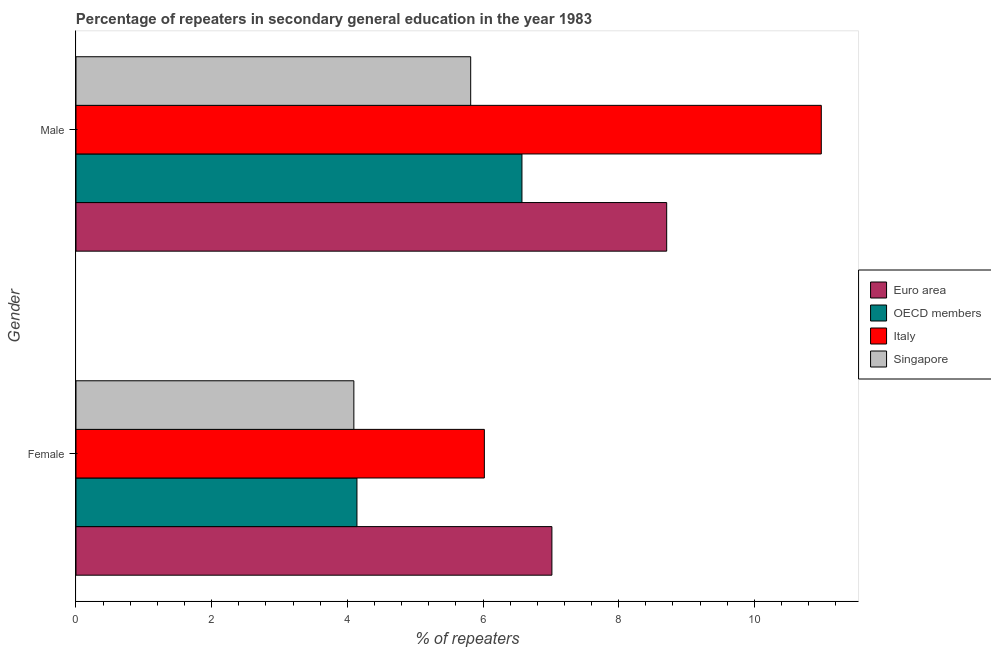Are the number of bars per tick equal to the number of legend labels?
Your answer should be very brief. Yes. Are the number of bars on each tick of the Y-axis equal?
Ensure brevity in your answer.  Yes. How many bars are there on the 2nd tick from the top?
Ensure brevity in your answer.  4. How many bars are there on the 1st tick from the bottom?
Offer a terse response. 4. What is the label of the 2nd group of bars from the top?
Ensure brevity in your answer.  Female. What is the percentage of male repeaters in Italy?
Your answer should be very brief. 10.99. Across all countries, what is the maximum percentage of female repeaters?
Ensure brevity in your answer.  7.02. Across all countries, what is the minimum percentage of male repeaters?
Give a very brief answer. 5.82. In which country was the percentage of male repeaters minimum?
Make the answer very short. Singapore. What is the total percentage of male repeaters in the graph?
Give a very brief answer. 32.09. What is the difference between the percentage of female repeaters in OECD members and that in Singapore?
Ensure brevity in your answer.  0.05. What is the difference between the percentage of male repeaters in Italy and the percentage of female repeaters in OECD members?
Your answer should be compact. 6.84. What is the average percentage of female repeaters per country?
Provide a succinct answer. 5.32. What is the difference between the percentage of female repeaters and percentage of male repeaters in OECD members?
Ensure brevity in your answer.  -2.43. What is the ratio of the percentage of female repeaters in Euro area to that in Singapore?
Your answer should be compact. 1.71. What does the 2nd bar from the top in Male represents?
Provide a succinct answer. Italy. What does the 4th bar from the bottom in Male represents?
Keep it short and to the point. Singapore. How many countries are there in the graph?
Your answer should be compact. 4. Does the graph contain any zero values?
Make the answer very short. No. Does the graph contain grids?
Your response must be concise. No. Where does the legend appear in the graph?
Ensure brevity in your answer.  Center right. What is the title of the graph?
Make the answer very short. Percentage of repeaters in secondary general education in the year 1983. Does "Kyrgyz Republic" appear as one of the legend labels in the graph?
Your answer should be compact. No. What is the label or title of the X-axis?
Your response must be concise. % of repeaters. What is the % of repeaters of Euro area in Female?
Provide a succinct answer. 7.02. What is the % of repeaters of OECD members in Female?
Provide a short and direct response. 4.14. What is the % of repeaters in Italy in Female?
Your answer should be compact. 6.02. What is the % of repeaters in Singapore in Female?
Make the answer very short. 4.1. What is the % of repeaters of Euro area in Male?
Ensure brevity in your answer.  8.71. What is the % of repeaters in OECD members in Male?
Provide a short and direct response. 6.57. What is the % of repeaters in Italy in Male?
Provide a short and direct response. 10.99. What is the % of repeaters in Singapore in Male?
Offer a terse response. 5.82. Across all Gender, what is the maximum % of repeaters in Euro area?
Provide a succinct answer. 8.71. Across all Gender, what is the maximum % of repeaters in OECD members?
Offer a terse response. 6.57. Across all Gender, what is the maximum % of repeaters of Italy?
Offer a very short reply. 10.99. Across all Gender, what is the maximum % of repeaters in Singapore?
Your answer should be very brief. 5.82. Across all Gender, what is the minimum % of repeaters in Euro area?
Offer a terse response. 7.02. Across all Gender, what is the minimum % of repeaters in OECD members?
Keep it short and to the point. 4.14. Across all Gender, what is the minimum % of repeaters of Italy?
Provide a short and direct response. 6.02. Across all Gender, what is the minimum % of repeaters in Singapore?
Offer a terse response. 4.1. What is the total % of repeaters of Euro area in the graph?
Offer a very short reply. 15.72. What is the total % of repeaters in OECD members in the graph?
Ensure brevity in your answer.  10.72. What is the total % of repeaters in Italy in the graph?
Ensure brevity in your answer.  17.01. What is the total % of repeaters in Singapore in the graph?
Your answer should be compact. 9.91. What is the difference between the % of repeaters of Euro area in Female and that in Male?
Offer a terse response. -1.69. What is the difference between the % of repeaters in OECD members in Female and that in Male?
Give a very brief answer. -2.43. What is the difference between the % of repeaters in Italy in Female and that in Male?
Provide a short and direct response. -4.97. What is the difference between the % of repeaters in Singapore in Female and that in Male?
Offer a terse response. -1.72. What is the difference between the % of repeaters of Euro area in Female and the % of repeaters of OECD members in Male?
Your answer should be compact. 0.44. What is the difference between the % of repeaters of Euro area in Female and the % of repeaters of Italy in Male?
Your answer should be very brief. -3.97. What is the difference between the % of repeaters in Euro area in Female and the % of repeaters in Singapore in Male?
Provide a succinct answer. 1.2. What is the difference between the % of repeaters in OECD members in Female and the % of repeaters in Italy in Male?
Ensure brevity in your answer.  -6.84. What is the difference between the % of repeaters in OECD members in Female and the % of repeaters in Singapore in Male?
Ensure brevity in your answer.  -1.68. What is the difference between the % of repeaters in Italy in Female and the % of repeaters in Singapore in Male?
Provide a short and direct response. 0.2. What is the average % of repeaters of Euro area per Gender?
Your response must be concise. 7.86. What is the average % of repeaters of OECD members per Gender?
Offer a terse response. 5.36. What is the average % of repeaters of Italy per Gender?
Offer a very short reply. 8.5. What is the average % of repeaters of Singapore per Gender?
Make the answer very short. 4.96. What is the difference between the % of repeaters in Euro area and % of repeaters in OECD members in Female?
Offer a terse response. 2.87. What is the difference between the % of repeaters of Euro area and % of repeaters of Singapore in Female?
Offer a very short reply. 2.92. What is the difference between the % of repeaters in OECD members and % of repeaters in Italy in Female?
Offer a very short reply. -1.88. What is the difference between the % of repeaters in OECD members and % of repeaters in Singapore in Female?
Provide a succinct answer. 0.05. What is the difference between the % of repeaters in Italy and % of repeaters in Singapore in Female?
Your answer should be very brief. 1.92. What is the difference between the % of repeaters of Euro area and % of repeaters of OECD members in Male?
Your answer should be compact. 2.13. What is the difference between the % of repeaters in Euro area and % of repeaters in Italy in Male?
Offer a very short reply. -2.28. What is the difference between the % of repeaters in Euro area and % of repeaters in Singapore in Male?
Give a very brief answer. 2.89. What is the difference between the % of repeaters in OECD members and % of repeaters in Italy in Male?
Your answer should be compact. -4.41. What is the difference between the % of repeaters of OECD members and % of repeaters of Singapore in Male?
Keep it short and to the point. 0.76. What is the difference between the % of repeaters of Italy and % of repeaters of Singapore in Male?
Make the answer very short. 5.17. What is the ratio of the % of repeaters of Euro area in Female to that in Male?
Provide a succinct answer. 0.81. What is the ratio of the % of repeaters of OECD members in Female to that in Male?
Offer a very short reply. 0.63. What is the ratio of the % of repeaters in Italy in Female to that in Male?
Provide a short and direct response. 0.55. What is the ratio of the % of repeaters in Singapore in Female to that in Male?
Offer a terse response. 0.7. What is the difference between the highest and the second highest % of repeaters in Euro area?
Provide a short and direct response. 1.69. What is the difference between the highest and the second highest % of repeaters in OECD members?
Offer a very short reply. 2.43. What is the difference between the highest and the second highest % of repeaters in Italy?
Offer a terse response. 4.97. What is the difference between the highest and the second highest % of repeaters in Singapore?
Offer a terse response. 1.72. What is the difference between the highest and the lowest % of repeaters in Euro area?
Ensure brevity in your answer.  1.69. What is the difference between the highest and the lowest % of repeaters in OECD members?
Ensure brevity in your answer.  2.43. What is the difference between the highest and the lowest % of repeaters of Italy?
Your answer should be compact. 4.97. What is the difference between the highest and the lowest % of repeaters of Singapore?
Provide a succinct answer. 1.72. 